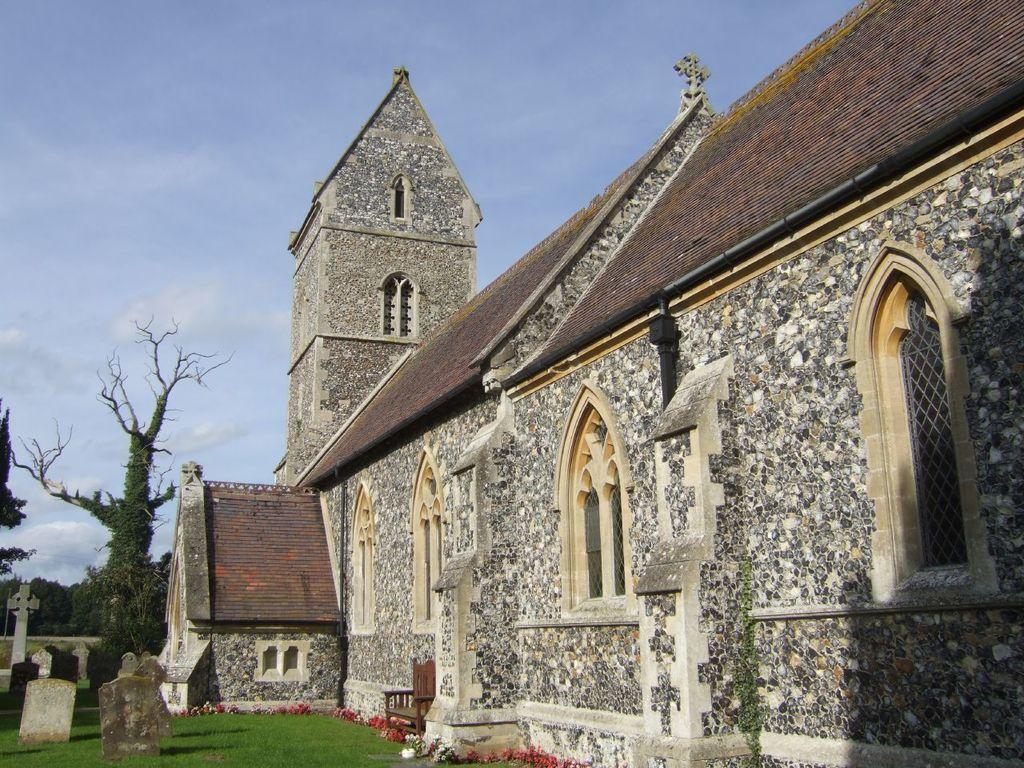How would you summarize this image in a sentence or two? This is an outside view. On the right side there is a building. In the background there are some trees. This place is looking like a graveyard. On the ground I can see the grass. At the top of the image I can see the sky. 